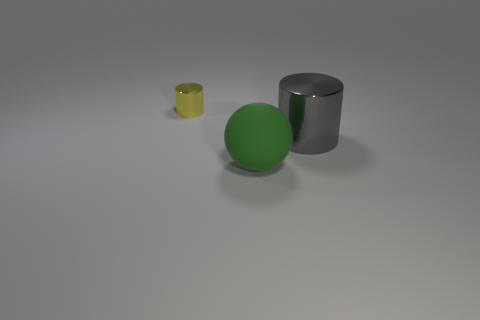If these items were part of a still life drawing, what mood would they convey? If they were part of a still life drawing, these objects might convey a mood of simplicity and minimalism. The understated colors and basic shapes give a sense of calm and order. The soft lighting and neutral background would emphasize the contemplative nature of such a scene. 